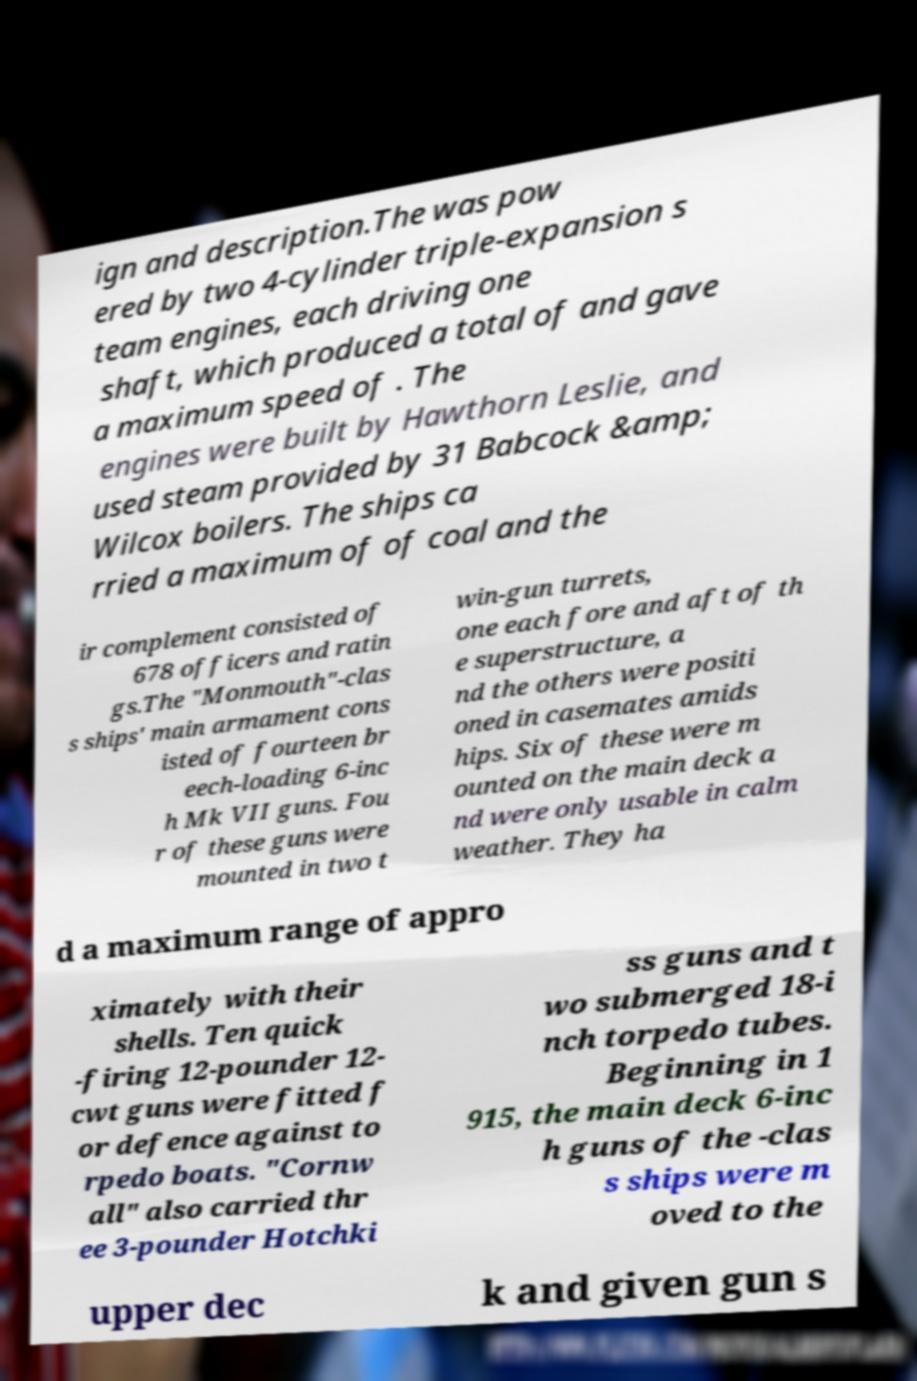I need the written content from this picture converted into text. Can you do that? ign and description.The was pow ered by two 4-cylinder triple-expansion s team engines, each driving one shaft, which produced a total of and gave a maximum speed of . The engines were built by Hawthorn Leslie, and used steam provided by 31 Babcock &amp; Wilcox boilers. The ships ca rried a maximum of of coal and the ir complement consisted of 678 officers and ratin gs.The "Monmouth"-clas s ships' main armament cons isted of fourteen br eech-loading 6-inc h Mk VII guns. Fou r of these guns were mounted in two t win-gun turrets, one each fore and aft of th e superstructure, a nd the others were positi oned in casemates amids hips. Six of these were m ounted on the main deck a nd were only usable in calm weather. They ha d a maximum range of appro ximately with their shells. Ten quick -firing 12-pounder 12- cwt guns were fitted f or defence against to rpedo boats. "Cornw all" also carried thr ee 3-pounder Hotchki ss guns and t wo submerged 18-i nch torpedo tubes. Beginning in 1 915, the main deck 6-inc h guns of the -clas s ships were m oved to the upper dec k and given gun s 